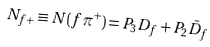<formula> <loc_0><loc_0><loc_500><loc_500>N _ { f + } \equiv N ( f \pi ^ { + } ) = P _ { 3 } D _ { f } + P _ { 2 } \bar { D } _ { f }</formula> 